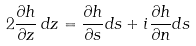Convert formula to latex. <formula><loc_0><loc_0><loc_500><loc_500>2 \frac { \partial h } { \partial z } \, d z = \frac { \partial h } { \partial s } d s + i \frac { \partial h } { \partial n } d s</formula> 